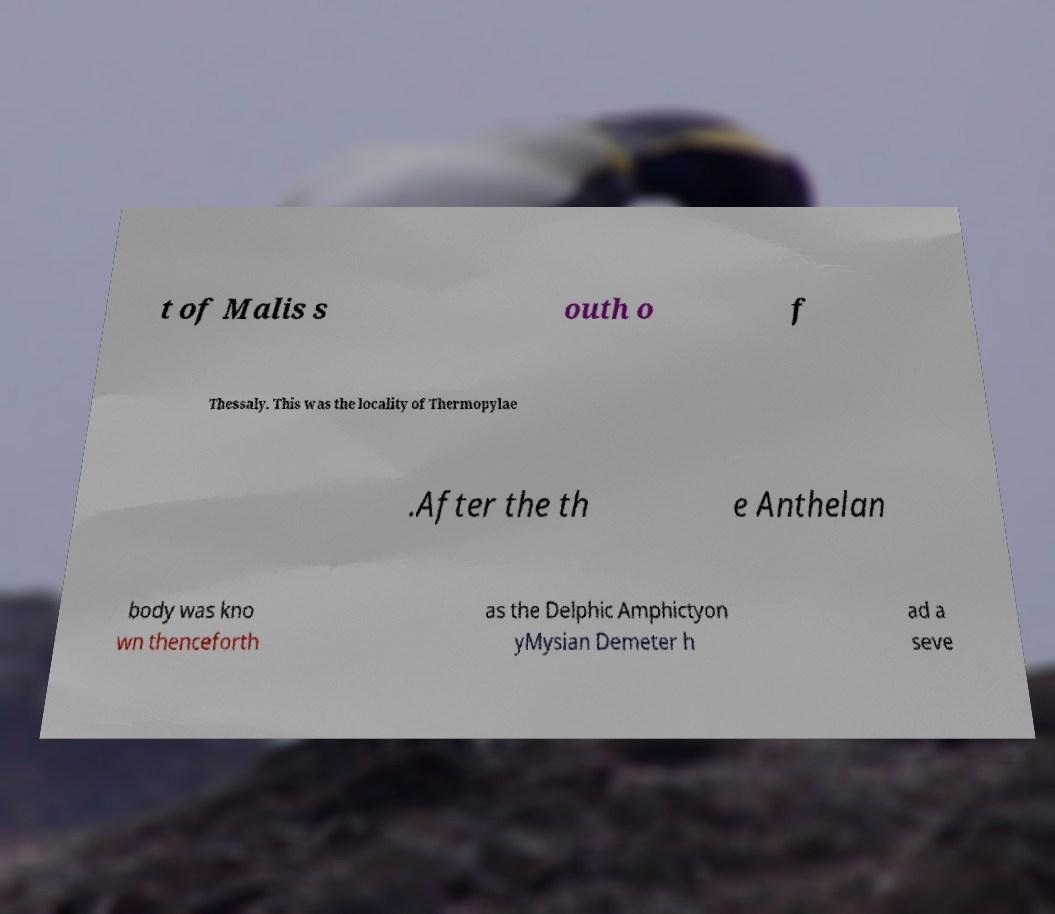Please identify and transcribe the text found in this image. t of Malis s outh o f Thessaly. This was the locality of Thermopylae .After the th e Anthelan body was kno wn thenceforth as the Delphic Amphictyon yMysian Demeter h ad a seve 